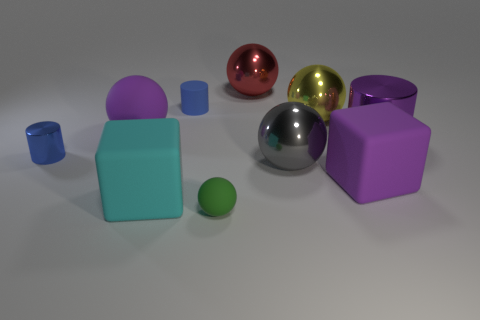There is a cylinder that is the same color as the big rubber sphere; what is its material?
Offer a very short reply. Metal. Are there any objects that have the same color as the large metal cylinder?
Your response must be concise. Yes. There is a metal object on the left side of the object behind the small rubber object that is behind the tiny green sphere; what color is it?
Your response must be concise. Blue. How many big brown rubber balls are there?
Ensure brevity in your answer.  0. How many large things are yellow balls or cyan blocks?
Provide a succinct answer. 2. What shape is the gray shiny thing that is the same size as the purple matte cube?
Offer a very short reply. Sphere. There is a tiny thing that is to the left of the small rubber thing behind the gray metal thing; what is it made of?
Give a very brief answer. Metal. Is the size of the green rubber sphere the same as the blue metal object?
Offer a very short reply. Yes. What number of objects are large rubber blocks in front of the big purple rubber cube or large yellow spheres?
Your response must be concise. 2. There is a purple thing right of the purple matte thing right of the gray ball; what shape is it?
Give a very brief answer. Cylinder. 